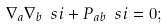Convert formula to latex. <formula><loc_0><loc_0><loc_500><loc_500>\nabla _ { a } \nabla _ { b } \ s i + P _ { a b } \ s i = 0 ;</formula> 